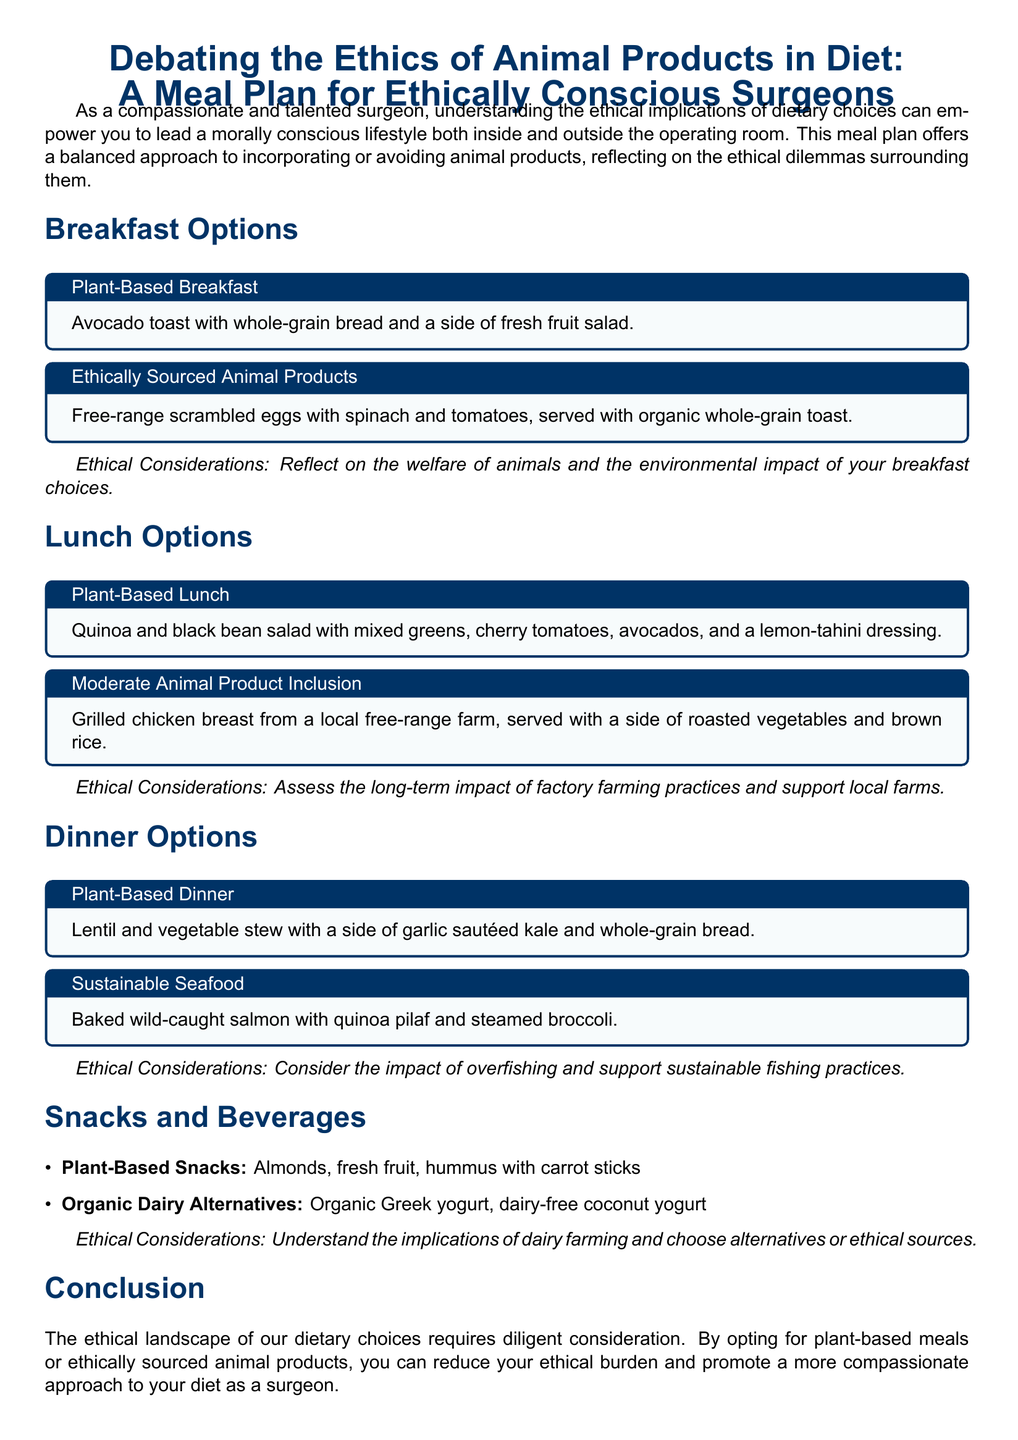What is the title of the meal plan? The title is the main heading that describes the document's purpose.
Answer: Debating the Ethics of Animal Products in Diet: A Meal Plan for Ethically Conscious Surgeons What is one plant-based breakfast option? This question focuses on the specific meals listed under the breakfast section.
Answer: Avocado toast with whole-grain bread and a side of fresh fruit salad Which protein source is used in the moderate animal product lunch option? This question asks for the specific type of animal product mentioned in the lunch options.
Answer: Grilled chicken breast What is one ethical consideration mentioned for the dinner options? This question looks for an ethical aspect discussed specifically in the dinner section.
Answer: Consider the impact of overfishing and support sustainable fishing practices How many sections are there in the meal plan? This requires counting the main sections that organize the content within the document.
Answer: Four What is the recommended snack option alongside hummus? This question targets a specific pairing mentioned in the snacks section.
Answer: Carrot sticks What type of seafood is suggested for dinner? This question asks for the specific kind of seafood included in the meal options.
Answer: Wild-caught salmon What is the primary focus of the conclusion? This question seeks to summarize the main message conveyed at the end of the document.
Answer: Ethical landscape of dietary choices Which meal option includes quinoa? The question aims to identify which meal listed contains quinoa as an ingredient.
Answer: Plant-Based Lunch 